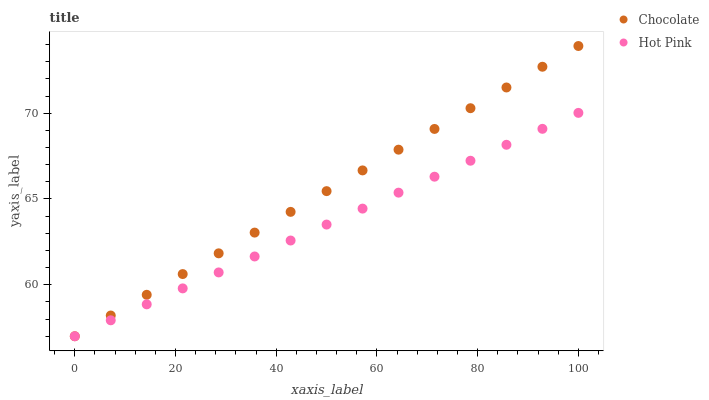Does Hot Pink have the minimum area under the curve?
Answer yes or no. Yes. Does Chocolate have the maximum area under the curve?
Answer yes or no. Yes. Does Chocolate have the minimum area under the curve?
Answer yes or no. No. Is Chocolate the smoothest?
Answer yes or no. Yes. Is Hot Pink the roughest?
Answer yes or no. Yes. Is Chocolate the roughest?
Answer yes or no. No. Does Hot Pink have the lowest value?
Answer yes or no. Yes. Does Chocolate have the highest value?
Answer yes or no. Yes. Does Chocolate intersect Hot Pink?
Answer yes or no. Yes. Is Chocolate less than Hot Pink?
Answer yes or no. No. Is Chocolate greater than Hot Pink?
Answer yes or no. No. 